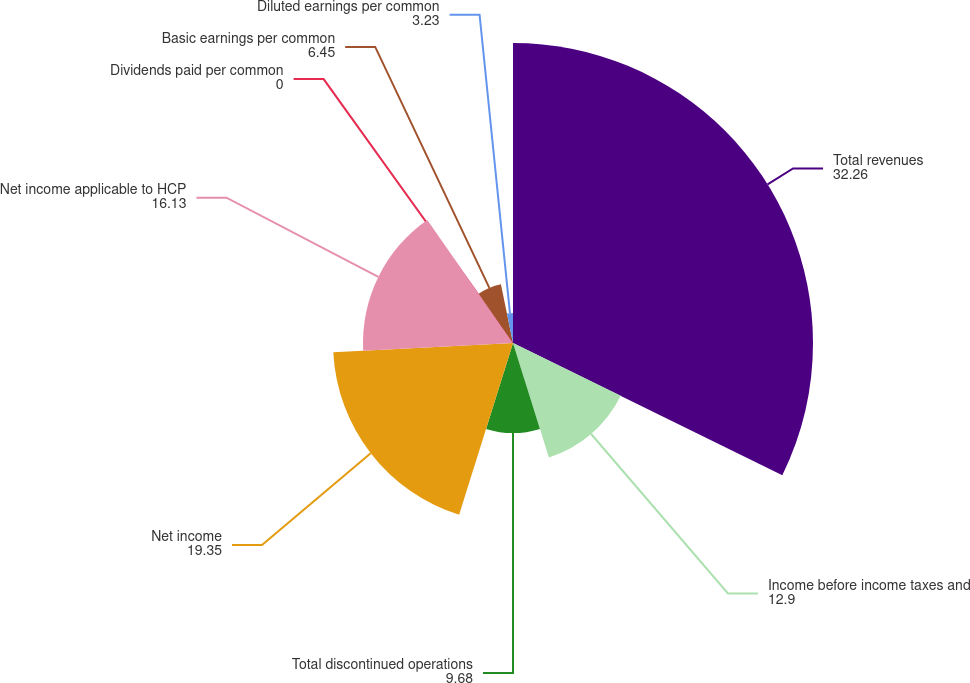Convert chart. <chart><loc_0><loc_0><loc_500><loc_500><pie_chart><fcel>Total revenues<fcel>Income before income taxes and<fcel>Total discontinued operations<fcel>Net income<fcel>Net income applicable to HCP<fcel>Dividends paid per common<fcel>Basic earnings per common<fcel>Diluted earnings per common<nl><fcel>32.26%<fcel>12.9%<fcel>9.68%<fcel>19.35%<fcel>16.13%<fcel>0.0%<fcel>6.45%<fcel>3.23%<nl></chart> 